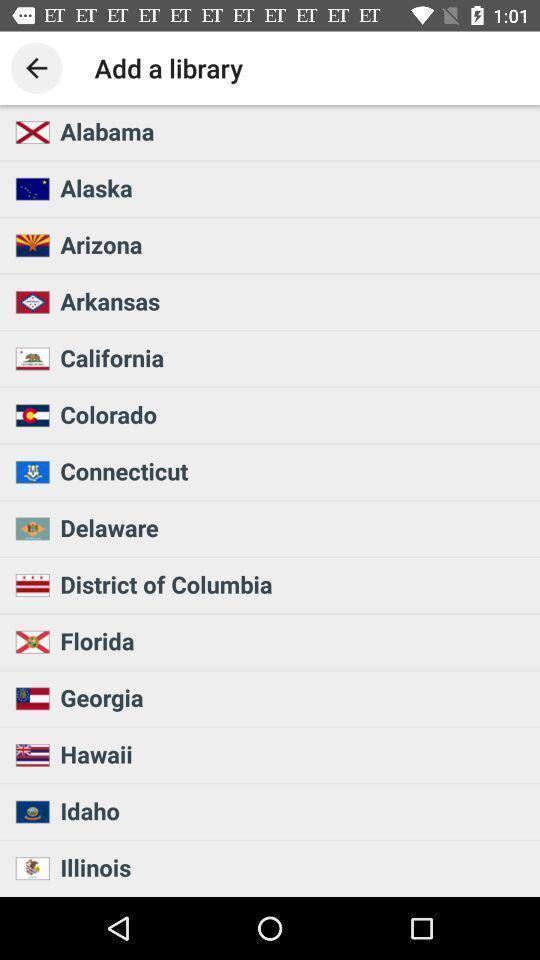Summarize the information in this screenshot. Page shows add a library with different countrie names. 